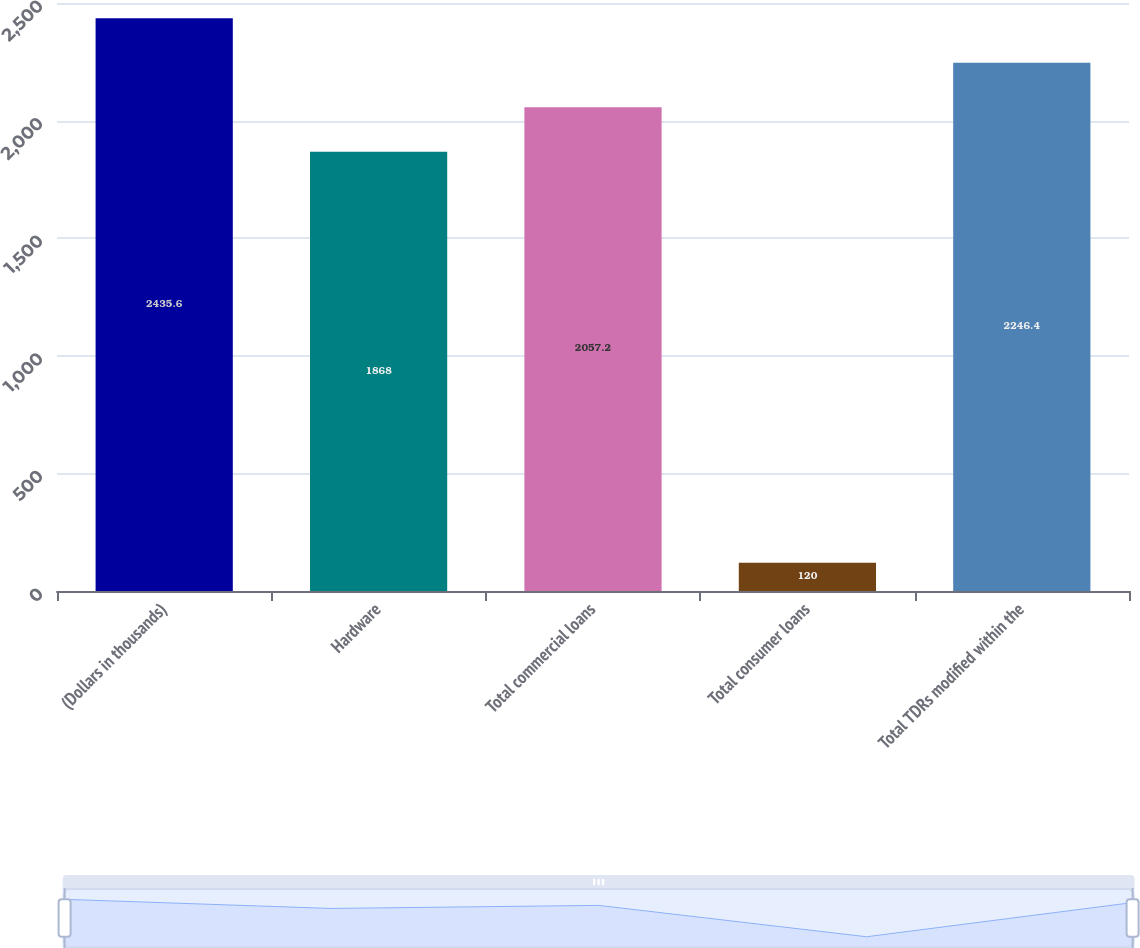Convert chart to OTSL. <chart><loc_0><loc_0><loc_500><loc_500><bar_chart><fcel>(Dollars in thousands)<fcel>Hardware<fcel>Total commercial loans<fcel>Total consumer loans<fcel>Total TDRs modified within the<nl><fcel>2435.6<fcel>1868<fcel>2057.2<fcel>120<fcel>2246.4<nl></chart> 